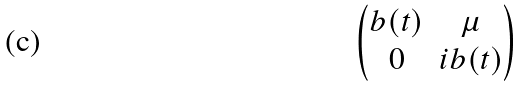<formula> <loc_0><loc_0><loc_500><loc_500>\begin{pmatrix} b ( t ) & \mu \\ 0 & i b ( t ) \end{pmatrix}</formula> 